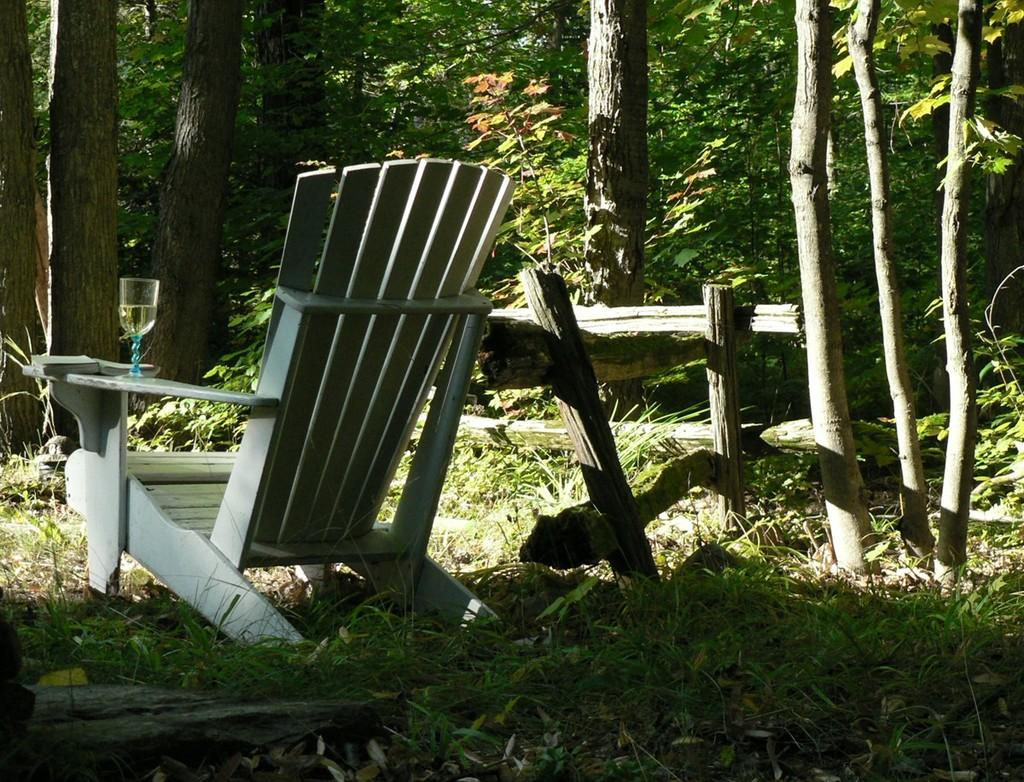What type of furniture is present in the image? There is a chair and a table in the image. What is placed on the table? There is a glass on the table. What can be seen in the background of the image? Trees and plants are visible in the image. How many leaves are on the chair in the image? There are no leaves present on the chair in the image. What type of sorting is being done by the plants in the image? The plants in the image are not performing any sorting activity. 